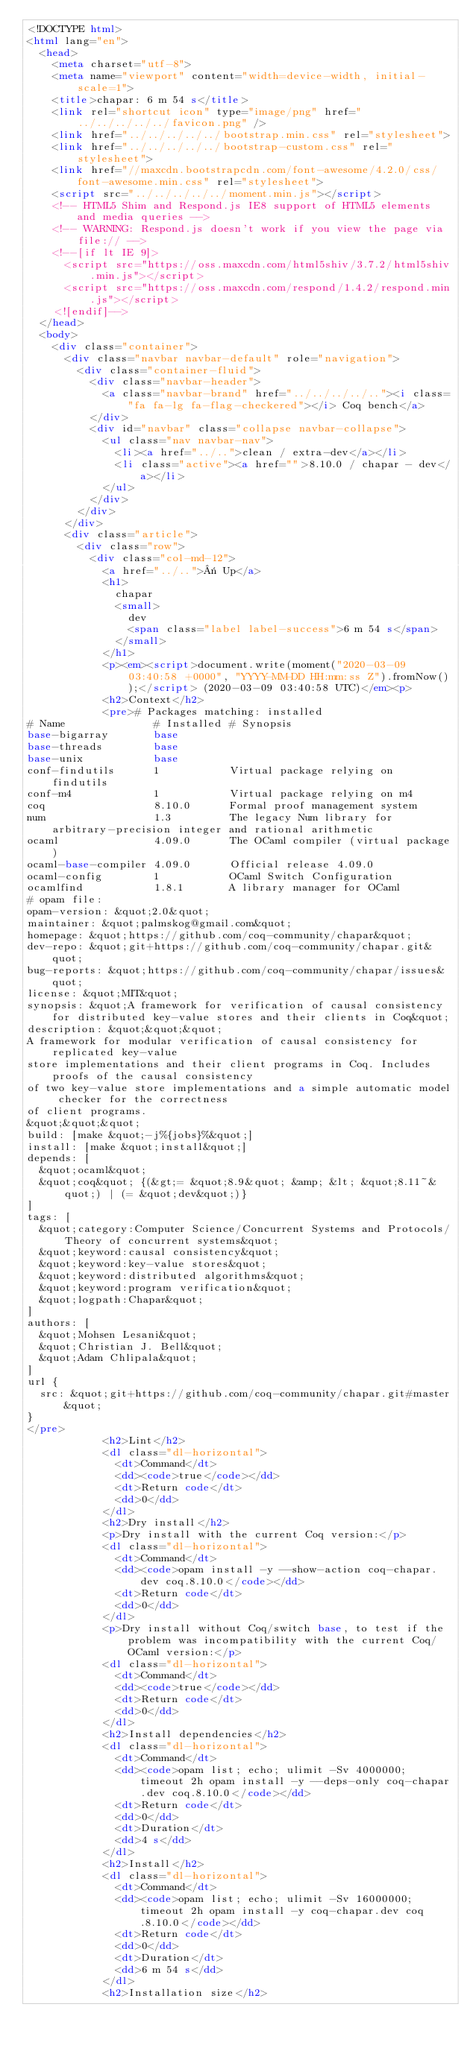Convert code to text. <code><loc_0><loc_0><loc_500><loc_500><_HTML_><!DOCTYPE html>
<html lang="en">
  <head>
    <meta charset="utf-8">
    <meta name="viewport" content="width=device-width, initial-scale=1">
    <title>chapar: 6 m 54 s</title>
    <link rel="shortcut icon" type="image/png" href="../../../../../favicon.png" />
    <link href="../../../../../bootstrap.min.css" rel="stylesheet">
    <link href="../../../../../bootstrap-custom.css" rel="stylesheet">
    <link href="//maxcdn.bootstrapcdn.com/font-awesome/4.2.0/css/font-awesome.min.css" rel="stylesheet">
    <script src="../../../../../moment.min.js"></script>
    <!-- HTML5 Shim and Respond.js IE8 support of HTML5 elements and media queries -->
    <!-- WARNING: Respond.js doesn't work if you view the page via file:// -->
    <!--[if lt IE 9]>
      <script src="https://oss.maxcdn.com/html5shiv/3.7.2/html5shiv.min.js"></script>
      <script src="https://oss.maxcdn.com/respond/1.4.2/respond.min.js"></script>
    <![endif]-->
  </head>
  <body>
    <div class="container">
      <div class="navbar navbar-default" role="navigation">
        <div class="container-fluid">
          <div class="navbar-header">
            <a class="navbar-brand" href="../../../../.."><i class="fa fa-lg fa-flag-checkered"></i> Coq bench</a>
          </div>
          <div id="navbar" class="collapse navbar-collapse">
            <ul class="nav navbar-nav">
              <li><a href="../..">clean / extra-dev</a></li>
              <li class="active"><a href="">8.10.0 / chapar - dev</a></li>
            </ul>
          </div>
        </div>
      </div>
      <div class="article">
        <div class="row">
          <div class="col-md-12">
            <a href="../..">« Up</a>
            <h1>
              chapar
              <small>
                dev
                <span class="label label-success">6 m 54 s</span>
              </small>
            </h1>
            <p><em><script>document.write(moment("2020-03-09 03:40:58 +0000", "YYYY-MM-DD HH:mm:ss Z").fromNow());</script> (2020-03-09 03:40:58 UTC)</em><p>
            <h2>Context</h2>
            <pre># Packages matching: installed
# Name              # Installed # Synopsis
base-bigarray       base
base-threads        base
base-unix           base
conf-findutils      1           Virtual package relying on findutils
conf-m4             1           Virtual package relying on m4
coq                 8.10.0      Formal proof management system
num                 1.3         The legacy Num library for arbitrary-precision integer and rational arithmetic
ocaml               4.09.0      The OCaml compiler (virtual package)
ocaml-base-compiler 4.09.0      Official release 4.09.0
ocaml-config        1           OCaml Switch Configuration
ocamlfind           1.8.1       A library manager for OCaml
# opam file:
opam-version: &quot;2.0&quot;
maintainer: &quot;palmskog@gmail.com&quot;
homepage: &quot;https://github.com/coq-community/chapar&quot;
dev-repo: &quot;git+https://github.com/coq-community/chapar.git&quot;
bug-reports: &quot;https://github.com/coq-community/chapar/issues&quot;
license: &quot;MIT&quot;
synopsis: &quot;A framework for verification of causal consistency for distributed key-value stores and their clients in Coq&quot;
description: &quot;&quot;&quot;
A framework for modular verification of causal consistency for replicated key-value
store implementations and their client programs in Coq. Includes proofs of the causal consistency
of two key-value store implementations and a simple automatic model checker for the correctness
of client programs.
&quot;&quot;&quot;
build: [make &quot;-j%{jobs}%&quot;]
install: [make &quot;install&quot;]
depends: [
  &quot;ocaml&quot;
  &quot;coq&quot; {(&gt;= &quot;8.9&quot; &amp; &lt; &quot;8.11~&quot;) | (= &quot;dev&quot;)}
]
tags: [
  &quot;category:Computer Science/Concurrent Systems and Protocols/Theory of concurrent systems&quot;
  &quot;keyword:causal consistency&quot;
  &quot;keyword:key-value stores&quot;
  &quot;keyword:distributed algorithms&quot;
  &quot;keyword:program verification&quot;
  &quot;logpath:Chapar&quot;
]
authors: [
  &quot;Mohsen Lesani&quot;
  &quot;Christian J. Bell&quot;
  &quot;Adam Chlipala&quot;
]
url {
  src: &quot;git+https://github.com/coq-community/chapar.git#master&quot;
}
</pre>
            <h2>Lint</h2>
            <dl class="dl-horizontal">
              <dt>Command</dt>
              <dd><code>true</code></dd>
              <dt>Return code</dt>
              <dd>0</dd>
            </dl>
            <h2>Dry install</h2>
            <p>Dry install with the current Coq version:</p>
            <dl class="dl-horizontal">
              <dt>Command</dt>
              <dd><code>opam install -y --show-action coq-chapar.dev coq.8.10.0</code></dd>
              <dt>Return code</dt>
              <dd>0</dd>
            </dl>
            <p>Dry install without Coq/switch base, to test if the problem was incompatibility with the current Coq/OCaml version:</p>
            <dl class="dl-horizontal">
              <dt>Command</dt>
              <dd><code>true</code></dd>
              <dt>Return code</dt>
              <dd>0</dd>
            </dl>
            <h2>Install dependencies</h2>
            <dl class="dl-horizontal">
              <dt>Command</dt>
              <dd><code>opam list; echo; ulimit -Sv 4000000; timeout 2h opam install -y --deps-only coq-chapar.dev coq.8.10.0</code></dd>
              <dt>Return code</dt>
              <dd>0</dd>
              <dt>Duration</dt>
              <dd>4 s</dd>
            </dl>
            <h2>Install</h2>
            <dl class="dl-horizontal">
              <dt>Command</dt>
              <dd><code>opam list; echo; ulimit -Sv 16000000; timeout 2h opam install -y coq-chapar.dev coq.8.10.0</code></dd>
              <dt>Return code</dt>
              <dd>0</dd>
              <dt>Duration</dt>
              <dd>6 m 54 s</dd>
            </dl>
            <h2>Installation size</h2></code> 